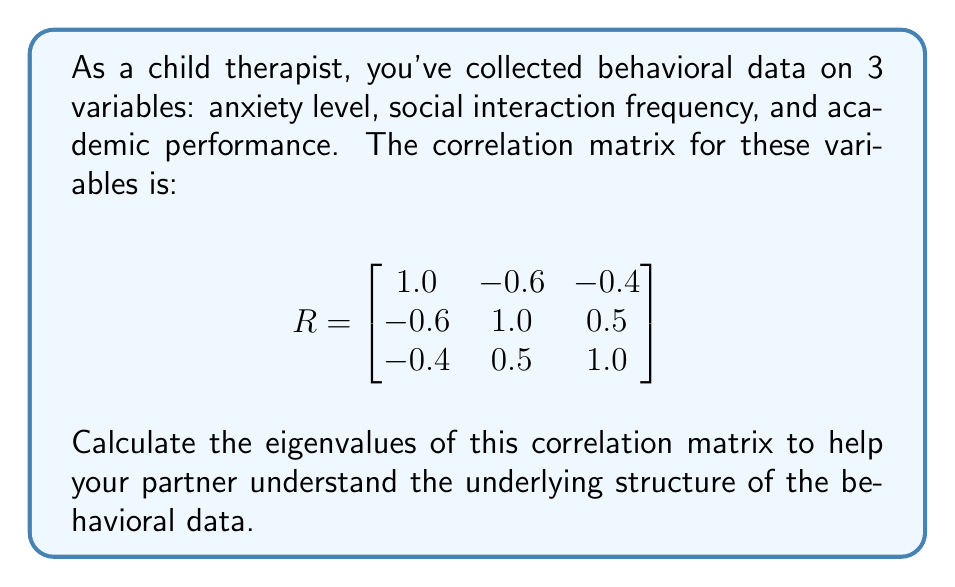Help me with this question. To find the eigenvalues of the correlation matrix R, we need to solve the characteristic equation:

$\det(R - \lambda I) = 0$

Where $\lambda$ represents the eigenvalues and $I$ is the 3x3 identity matrix.

Step 1: Set up the characteristic equation
$$
\det \begin{pmatrix}
1-\lambda & -0.6 & -0.4 \\
-0.6 & 1-\lambda & 0.5 \\
-0.4 & 0.5 & 1-\lambda
\end{pmatrix} = 0
$$

Step 2: Calculate the determinant
$$(1-\lambda)[(1-\lambda)(1-\lambda) - 0.25] + (-0.6)[(-0.6)(1-\lambda) + 0.2] + (-0.4)[(-0.6)(0.5) + (-0.4)(1-\lambda)] = 0$$

Step 3: Expand and simplify
$$-\lambda^3 + 3\lambda^2 - 0.51\lambda - 0.49 = 0$$

Step 4: Solve the cubic equation
This can be solved using the cubic formula or numerical methods. The solutions are:

$\lambda_1 \approx 2.1543$
$\lambda_2 \approx 0.6861$
$\lambda_3 \approx 0.1596$

These are the eigenvalues of the correlation matrix.
Answer: $\lambda_1 \approx 2.1543$, $\lambda_2 \approx 0.6861$, $\lambda_3 \approx 0.1596$ 